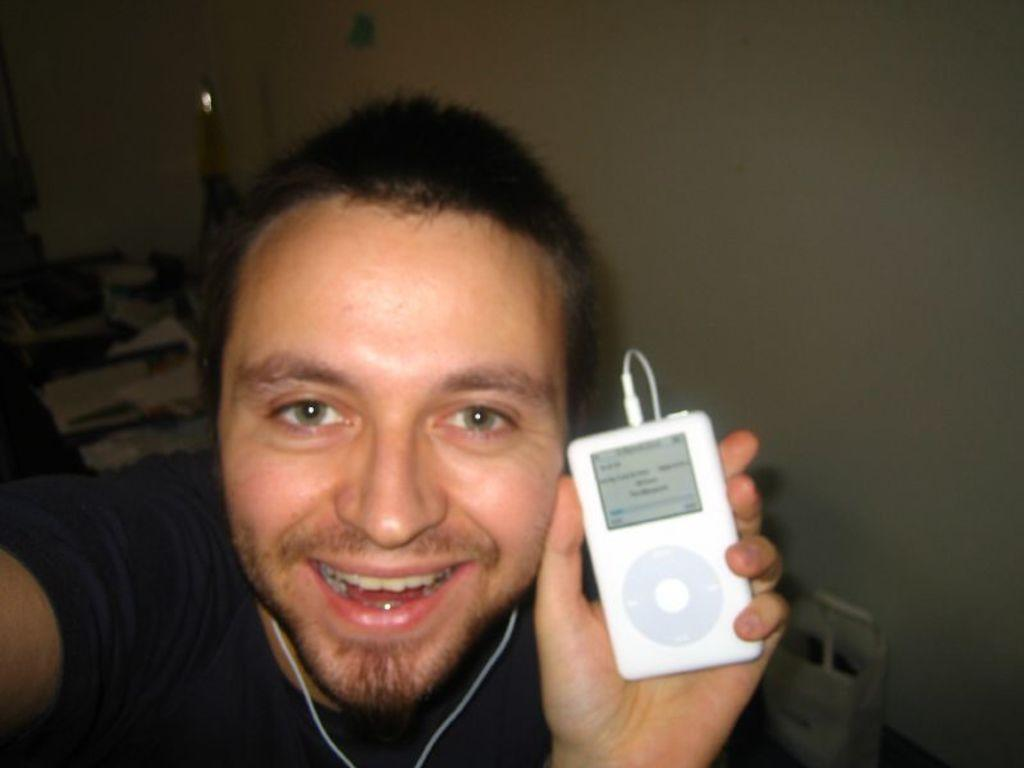What is the man in the image holding? The man is holding an iPod. Can you describe the iPod in the image? The iPod is white in color. How is the man listening to the iPod? The man is using earphones. What type of fruit is the man offering to someone in the image? There is no fruit present in the image, and the man is not offering anything to anyone. What is the man using to pull a yoke in the image? There is no yoke present in the image, and the man is not pulling anything. 